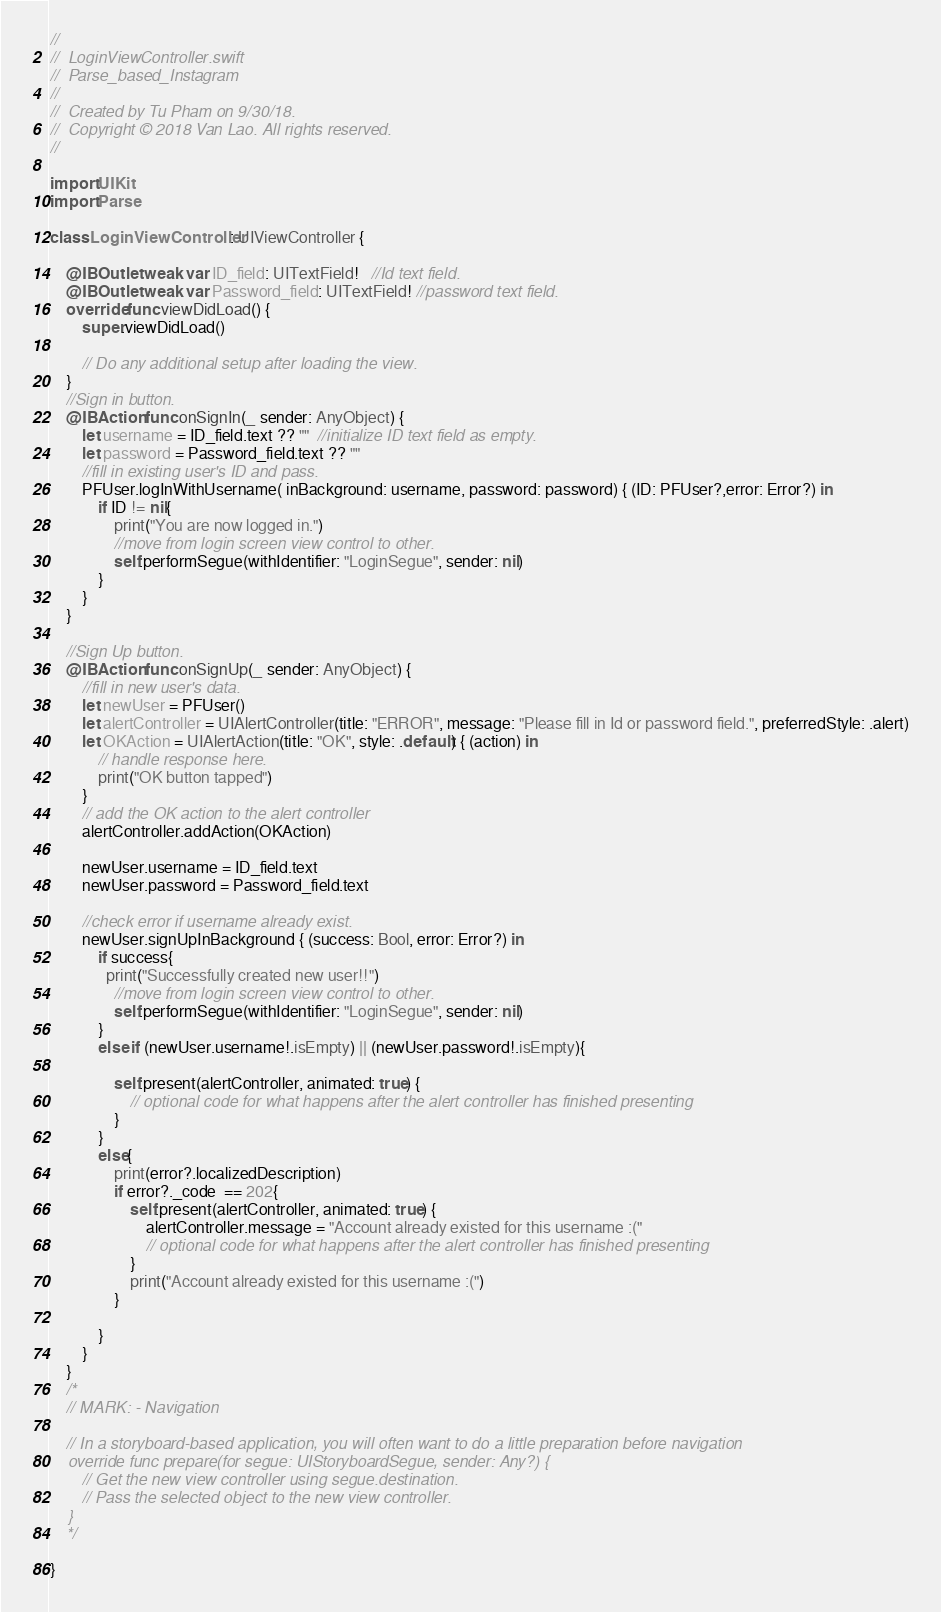Convert code to text. <code><loc_0><loc_0><loc_500><loc_500><_Swift_>//
//  LoginViewController.swift
//  Parse_based_Instagram
//
//  Created by Tu Pham on 9/30/18.
//  Copyright © 2018 Van Lao. All rights reserved.
//

import UIKit
import Parse

class LoginViewController: UIViewController {

    @IBOutlet weak var ID_field: UITextField!   //Id text field.
    @IBOutlet weak var Password_field: UITextField! //password text field.
    override func viewDidLoad() {
        super.viewDidLoad()

        // Do any additional setup after loading the view.
    }
    //Sign in button.
    @IBAction func onSignIn(_ sender: AnyObject) {
        let username = ID_field.text ?? ""  //initialize ID text field as empty.
        let password = Password_field.text ?? ""
        //fill in existing user's ID and pass.
        PFUser.logInWithUsername( inBackground: username, password: password) { (ID: PFUser?,error: Error?) in
            if ID != nil{
                print("You are now logged in.")
                //move from login screen view control to other.
                self.performSegue(withIdentifier: "LoginSegue", sender: nil)
            }
        }
    }
    
    //Sign Up button.
    @IBAction func onSignUp(_ sender: AnyObject) {
        //fill in new user's data.
        let newUser = PFUser()
        let alertController = UIAlertController(title: "ERROR", message: "Please fill in Id or password field.", preferredStyle: .alert)
        let OKAction = UIAlertAction(title: "OK", style: .default) { (action) in
            // handle response here.
            print("OK button tapped")
        }
        // add the OK action to the alert controller
        alertController.addAction(OKAction)
        
        newUser.username = ID_field.text
        newUser.password = Password_field.text
        
        //check error if username already exist.
        newUser.signUpInBackground { (success: Bool, error: Error?) in
            if success{
              print("Successfully created new user!!")
                //move from login screen view control to other.
                self.performSegue(withIdentifier: "LoginSegue", sender: nil)
            }
            else if (newUser.username!.isEmpty) || (newUser.password!.isEmpty){
                
                self.present(alertController, animated: true) {
                    // optional code for what happens after the alert controller has finished presenting
                }
            }
            else{
                print(error?.localizedDescription)
                if error?._code  == 202{
                    self.present(alertController, animated: true) {
                        alertController.message = "Account already existed for this username :("
                        // optional code for what happens after the alert controller has finished presenting
                    }
                    print("Account already existed for this username :(")
                }
                
            }
        }
    }
    /*
    // MARK: - Navigation

    // In a storyboard-based application, you will often want to do a little preparation before navigation
    override func prepare(for segue: UIStoryboardSegue, sender: Any?) {
        // Get the new view controller using segue.destination.
        // Pass the selected object to the new view controller.
    }
    */

}
</code> 